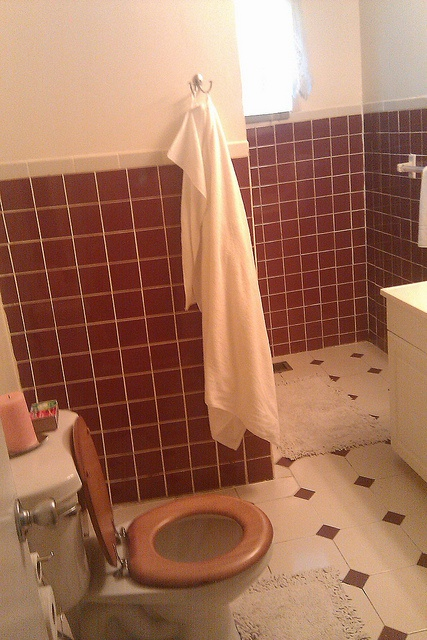Describe the objects in this image and their specific colors. I can see a toilet in tan, brown, and maroon tones in this image. 